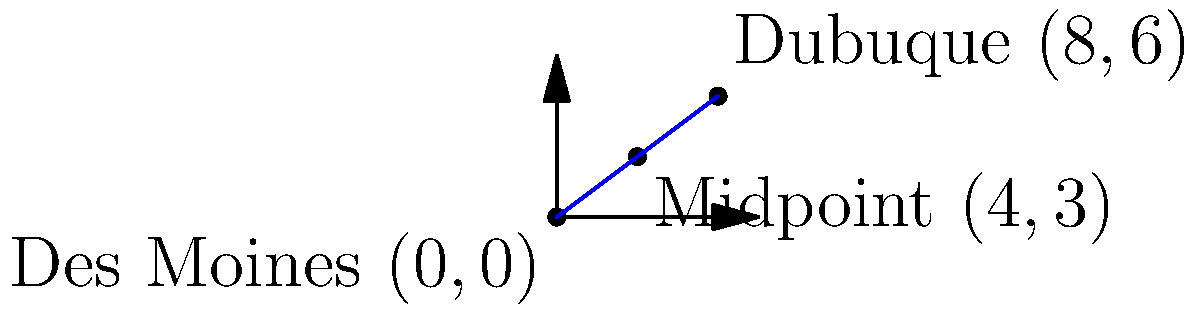As a veteran transitioning to civilian life in Iowa, you're planning a road trip to explore the state. You want to find a meeting point with a friend who's in a different city. On a coordinate plane where Des Moines is at $(0,0)$ and Dubuque is at $(8,6)$, calculate the coordinates of the midpoint between these two cities. To find the midpoint of a line segment, we use the midpoint formula:

$$ \text{Midpoint} = \left(\frac{x_1 + x_2}{2}, \frac{y_1 + y_2}{2}\right) $$

Where $(x_1, y_1)$ are the coordinates of the first point and $(x_2, y_2)$ are the coordinates of the second point.

Given:
- Des Moines: $(0,0)$
- Dubuque: $(8,6)$

Step 1: Calculate the x-coordinate of the midpoint:
$$ x = \frac{x_1 + x_2}{2} = \frac{0 + 8}{2} = \frac{8}{2} = 4 $$

Step 2: Calculate the y-coordinate of the midpoint:
$$ y = \frac{y_1 + y_2}{2} = \frac{0 + 6}{2} = \frac{6}{2} = 3 $$

Therefore, the midpoint coordinates are $(4,3)$.
Answer: $(4,3)$ 